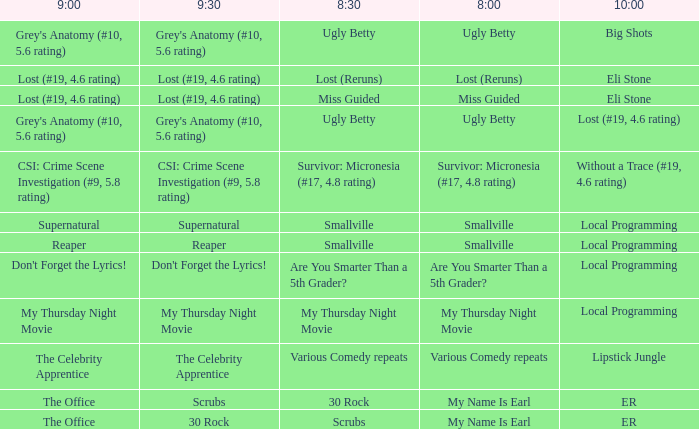What is at 10:00 when at 8:30 it is scrubs? ER. 